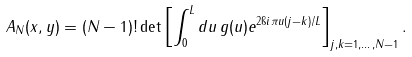<formula> <loc_0><loc_0><loc_500><loc_500>A _ { N } ( x , y ) = ( N - 1 ) ! \det \left [ \int _ { 0 } ^ { L } d u \, g ( u ) e ^ { 2 \i i \pi u ( j - k ) / L } \right ] _ { j , k = 1 , \dots , N - 1 } .</formula> 